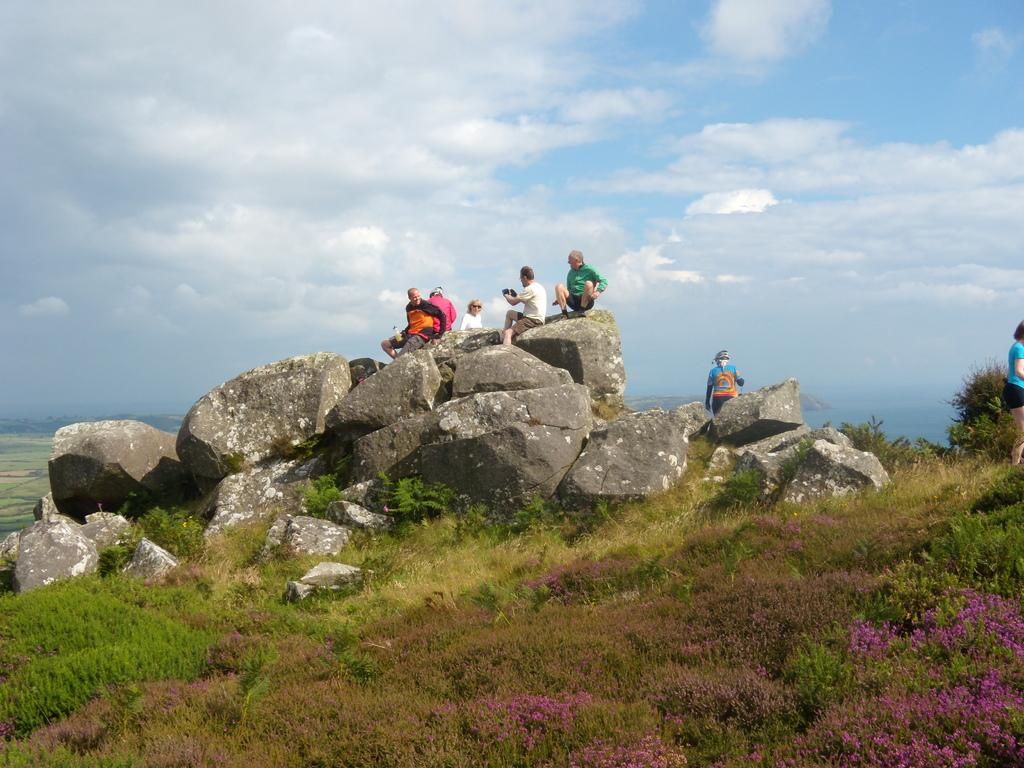What are the persons in the image doing? The persons in the image are sitting on the rocks. What type of vegetation is present at the bottom of the image? There is green grass at the bottom of the image. What can be seen in the sky in the background of the image? There are clouds visible in the sky in the background of the image. What type of humor can be seen in the prison in the image? There is no prison present in the image, and therefore no humor related to a prison can be observed. 